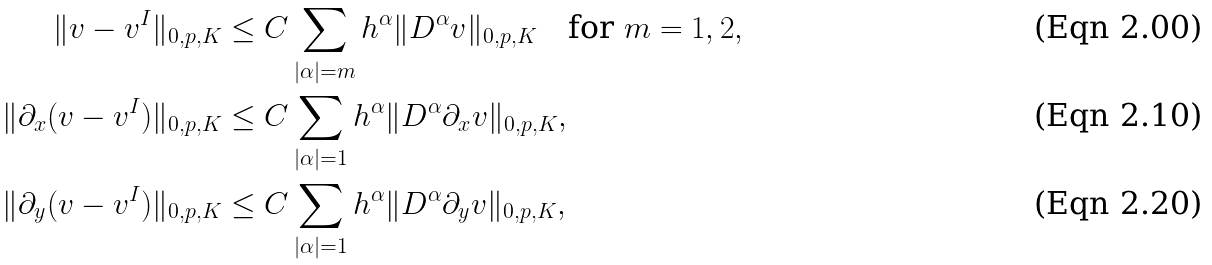Convert formula to latex. <formula><loc_0><loc_0><loc_500><loc_500>\| v - v ^ { I } \| _ { 0 , p , K } & \leq C \sum _ { | \alpha | = m } h ^ { \alpha } \| D ^ { \alpha } v \| _ { 0 , p , K } \quad \text {for } m = 1 , 2 , \\ \| \partial _ { x } ( v - v ^ { I } ) \| _ { 0 , p , K } & \leq C \sum _ { | \alpha | = 1 } h ^ { \alpha } \| D ^ { \alpha } \partial _ { x } v \| _ { 0 , p , K } , \\ \| \partial _ { y } ( v - v ^ { I } ) \| _ { 0 , p , K } & \leq C \sum _ { | \alpha | = 1 } h ^ { \alpha } \| D ^ { \alpha } \partial _ { y } v \| _ { 0 , p , K } ,</formula> 